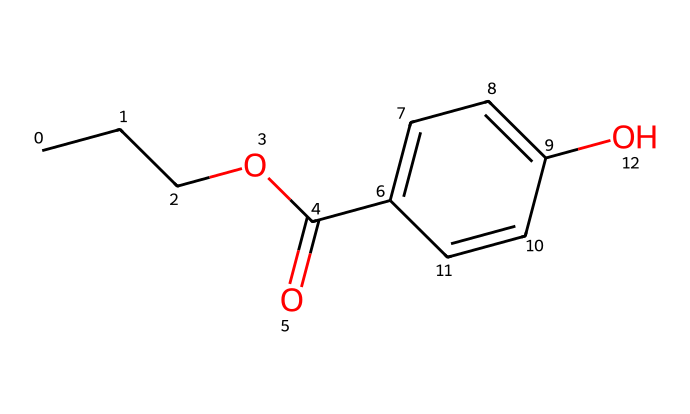What is the molecular formula of propylparaben? To determine the molecular formula, count the number of each type of atom in the SMILES representation. The atoms are C (Carbon), H (Hydrogen), O (Oxygen). From the SMILES, there are 10 Carbons, 12 Hydrogens, and 4 Oxygens. Therefore, the molecular formula is C10H12O4.
Answer: C10H12O4 How many carbon atoms are in propylparaben? Count the number of carbon (C) symbols in the SMILES representation. There are 10 carbon atoms present in the chemical structure.
Answer: 10 What type of functional group is present in propylparaben? Analyze the SMILES to identify functional groups. The presence of the -O- (ether) and -C(=O)- (ester) suggests that the compound contains ester functionality. Therefore, the functional group present is an ester.
Answer: ester How many rings are present in the structure of propylparaben? Observing the SMILES representation, identify any cyclic structures. The notation "C1" indicates a cyclic arrangement of carbon atoms. The chemical has one ring present in its structure.
Answer: 1 Is propylparaben typically considered a preservative? Knowledge of chemical applications indicates that propylparaben is widely used as a preservative in cosmetics and personal care products. Therefore, it is typically considered a preservative.
Answer: yes What is the significance of the hydroxy (-OH) group in propylparaben? The hydroxy (-OH) group can influence the chemical's solubility and reactivity. It plays a crucial role in the antibacterial and antifungal properties of propylparaben, which contributes to its efficacy as a preservative.
Answer: antibacterial properties What type of reactions can propylparaben undergo due to the ester functional group? Ester functional groups are known to undergo hydrolysis and alcoholysis reactions. In the presence of water or an alcohol, propylparaben can break down into its constituent acids and alcohols. Thus, possible reactions include hydrolysis and alcoholysis.
Answer: hydrolysis 